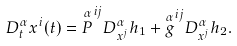Convert formula to latex. <formula><loc_0><loc_0><loc_500><loc_500>D _ { t } ^ { \alpha } x ^ { i } ( t ) = { \overset { \alpha } { P } } ^ { i j } D _ { x ^ { j } } ^ { \alpha } h _ { 1 } + { \overset { \alpha } { g } } ^ { i j } D _ { x ^ { j } } ^ { \alpha } h _ { 2 } .</formula> 